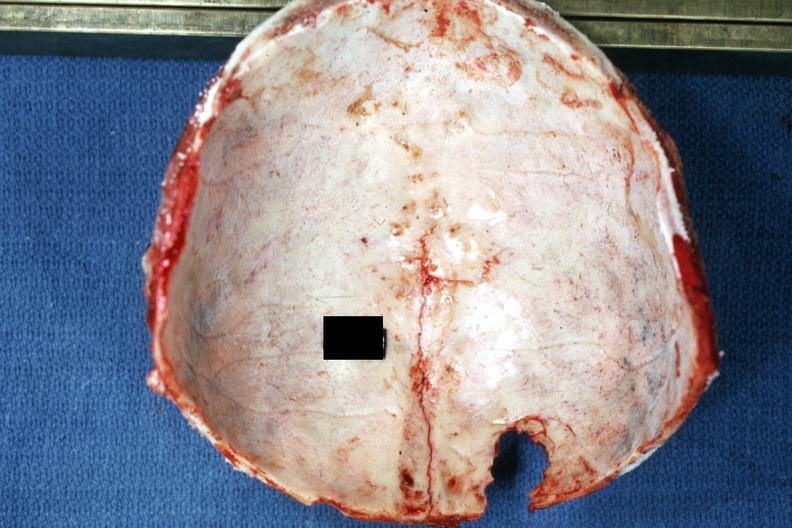what does this image show?
Answer the question using a single word or phrase. Easily seen lesion extending up midline to vertex 